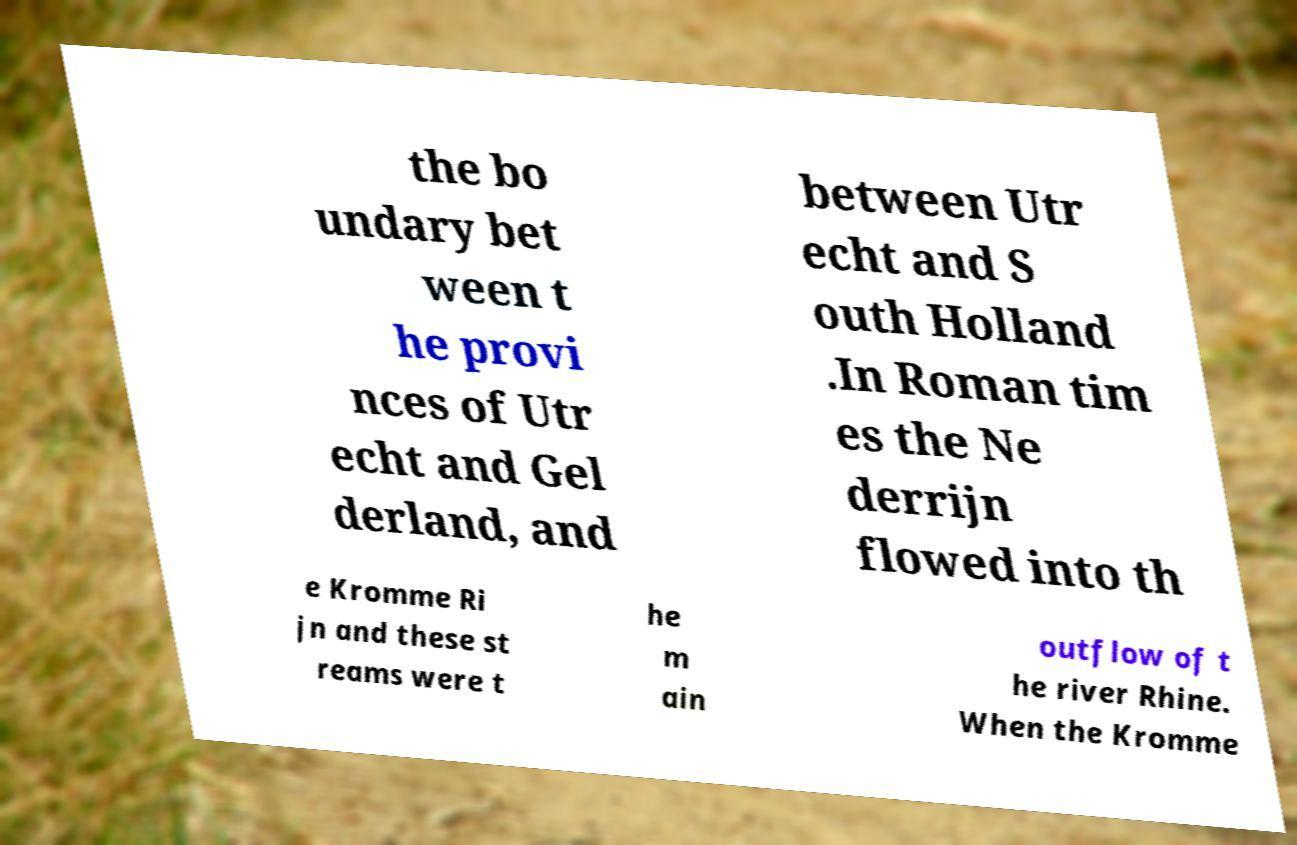Could you assist in decoding the text presented in this image and type it out clearly? the bo undary bet ween t he provi nces of Utr echt and Gel derland, and between Utr echt and S outh Holland .In Roman tim es the Ne derrijn flowed into th e Kromme Ri jn and these st reams were t he m ain outflow of t he river Rhine. When the Kromme 